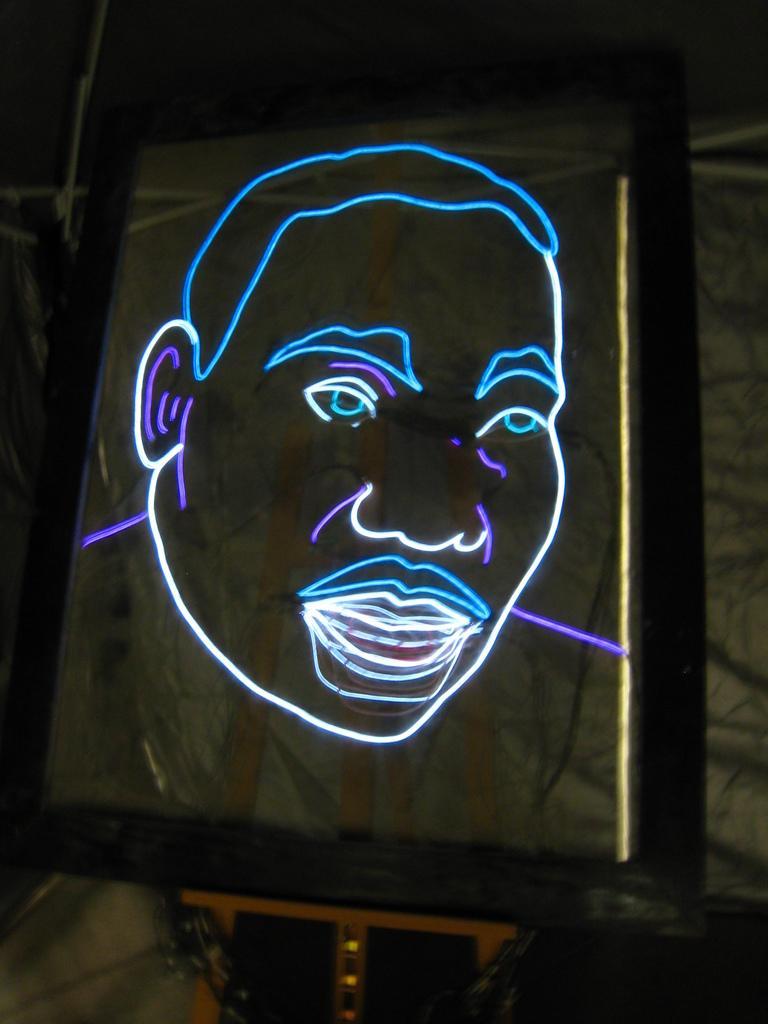Can you describe this image briefly? In this picture I can see the neon sign of a face of a man, on the glass object, which is on the drawing stand, and in the background there are some objects. 